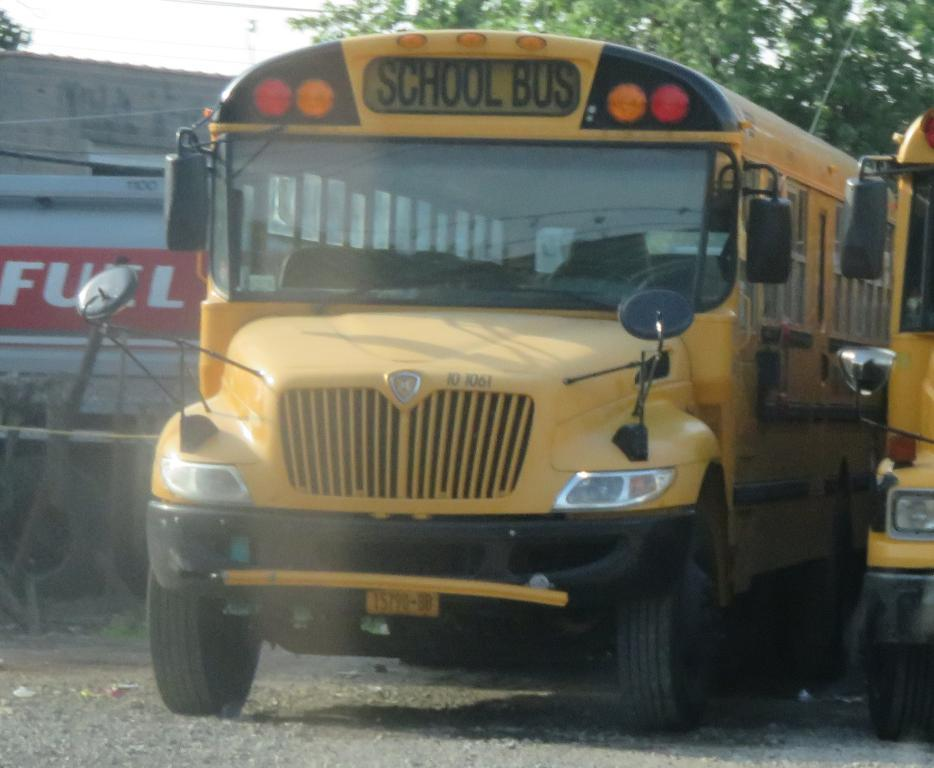What type of vehicles are in the middle of the image? There are school buses in the middle of the image. What can be seen in the background of the image? There is a building and trees in the background of the image. What type of carriage is being pulled by horses in the image? There is no carriage or horses present in the image; it features school buses and a background with a building and trees. 